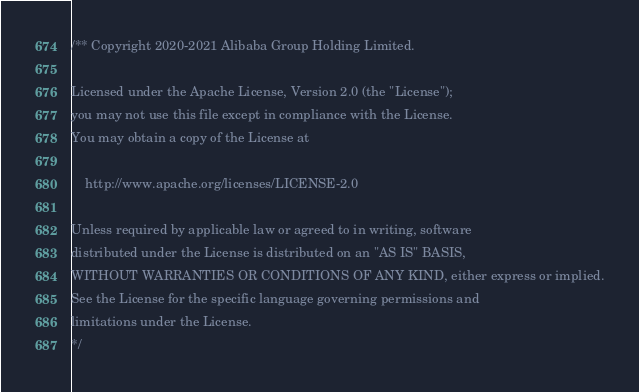Convert code to text. <code><loc_0><loc_0><loc_500><loc_500><_C_>/** Copyright 2020-2021 Alibaba Group Holding Limited.

Licensed under the Apache License, Version 2.0 (the "License");
you may not use this file except in compliance with the License.
You may obtain a copy of the License at

    http://www.apache.org/licenses/LICENSE-2.0

Unless required by applicable law or agreed to in writing, software
distributed under the License is distributed on an "AS IS" BASIS,
WITHOUT WARRANTIES OR CONDITIONS OF ANY KIND, either express or implied.
See the License for the specific language governing permissions and
limitations under the License.
*/
</code> 